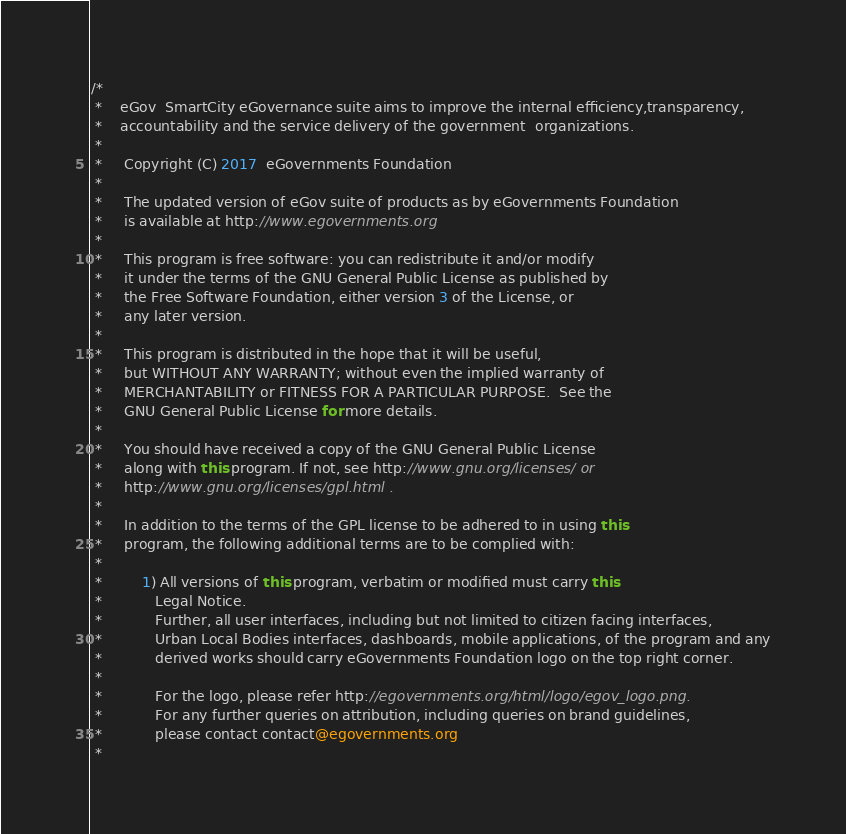Convert code to text. <code><loc_0><loc_0><loc_500><loc_500><_Java_>/*
 *    eGov  SmartCity eGovernance suite aims to improve the internal efficiency,transparency,
 *    accountability and the service delivery of the government  organizations.
 *
 *     Copyright (C) 2017  eGovernments Foundation
 *
 *     The updated version of eGov suite of products as by eGovernments Foundation
 *     is available at http://www.egovernments.org
 *
 *     This program is free software: you can redistribute it and/or modify
 *     it under the terms of the GNU General Public License as published by
 *     the Free Software Foundation, either version 3 of the License, or
 *     any later version.
 *
 *     This program is distributed in the hope that it will be useful,
 *     but WITHOUT ANY WARRANTY; without even the implied warranty of
 *     MERCHANTABILITY or FITNESS FOR A PARTICULAR PURPOSE.  See the
 *     GNU General Public License for more details.
 *
 *     You should have received a copy of the GNU General Public License
 *     along with this program. If not, see http://www.gnu.org/licenses/ or
 *     http://www.gnu.org/licenses/gpl.html .
 *
 *     In addition to the terms of the GPL license to be adhered to in using this
 *     program, the following additional terms are to be complied with:
 *
 *         1) All versions of this program, verbatim or modified must carry this
 *            Legal Notice.
 *            Further, all user interfaces, including but not limited to citizen facing interfaces,
 *            Urban Local Bodies interfaces, dashboards, mobile applications, of the program and any
 *            derived works should carry eGovernments Foundation logo on the top right corner.
 *
 *            For the logo, please refer http://egovernments.org/html/logo/egov_logo.png.
 *            For any further queries on attribution, including queries on brand guidelines,
 *            please contact contact@egovernments.org
 *</code> 